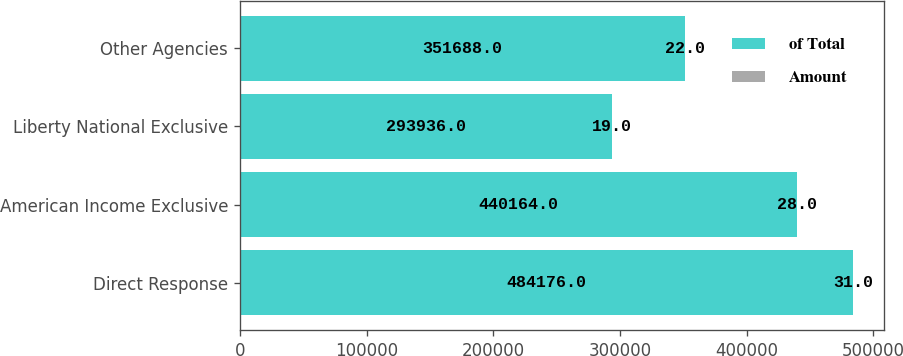<chart> <loc_0><loc_0><loc_500><loc_500><stacked_bar_chart><ecel><fcel>Direct Response<fcel>American Income Exclusive<fcel>Liberty National Exclusive<fcel>Other Agencies<nl><fcel>of Total<fcel>484176<fcel>440164<fcel>293936<fcel>351688<nl><fcel>Amount<fcel>31<fcel>28<fcel>19<fcel>22<nl></chart> 